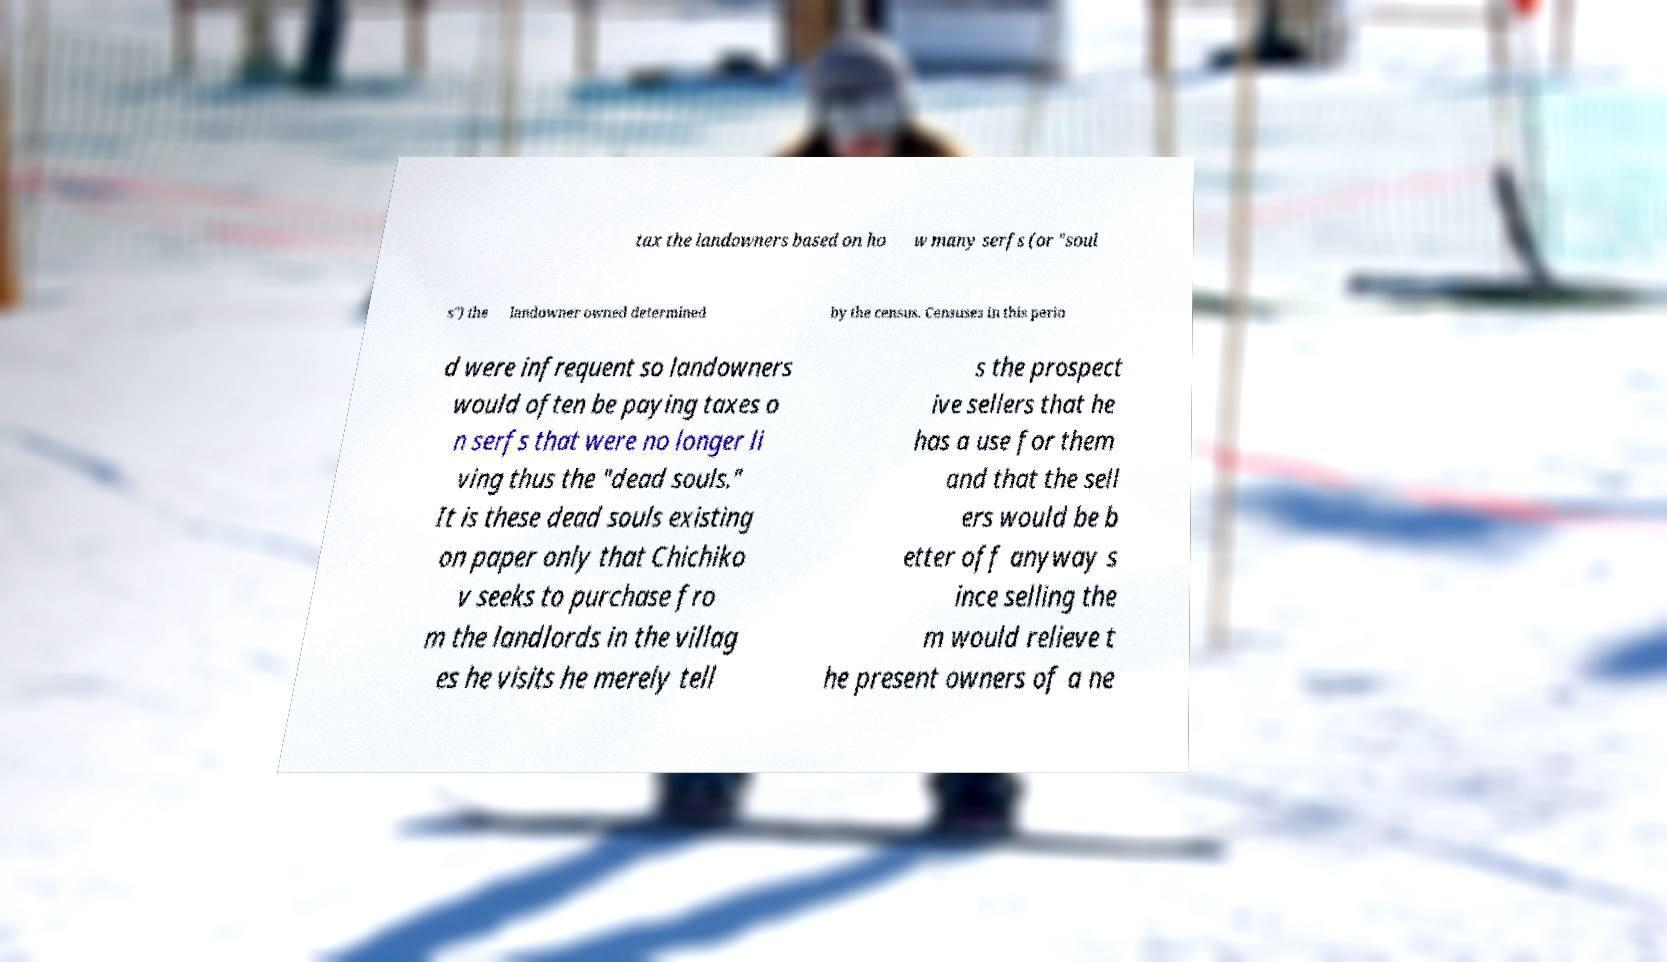What messages or text are displayed in this image? I need them in a readable, typed format. tax the landowners based on ho w many serfs (or "soul s") the landowner owned determined by the census. Censuses in this perio d were infrequent so landowners would often be paying taxes o n serfs that were no longer li ving thus the "dead souls." It is these dead souls existing on paper only that Chichiko v seeks to purchase fro m the landlords in the villag es he visits he merely tell s the prospect ive sellers that he has a use for them and that the sell ers would be b etter off anyway s ince selling the m would relieve t he present owners of a ne 